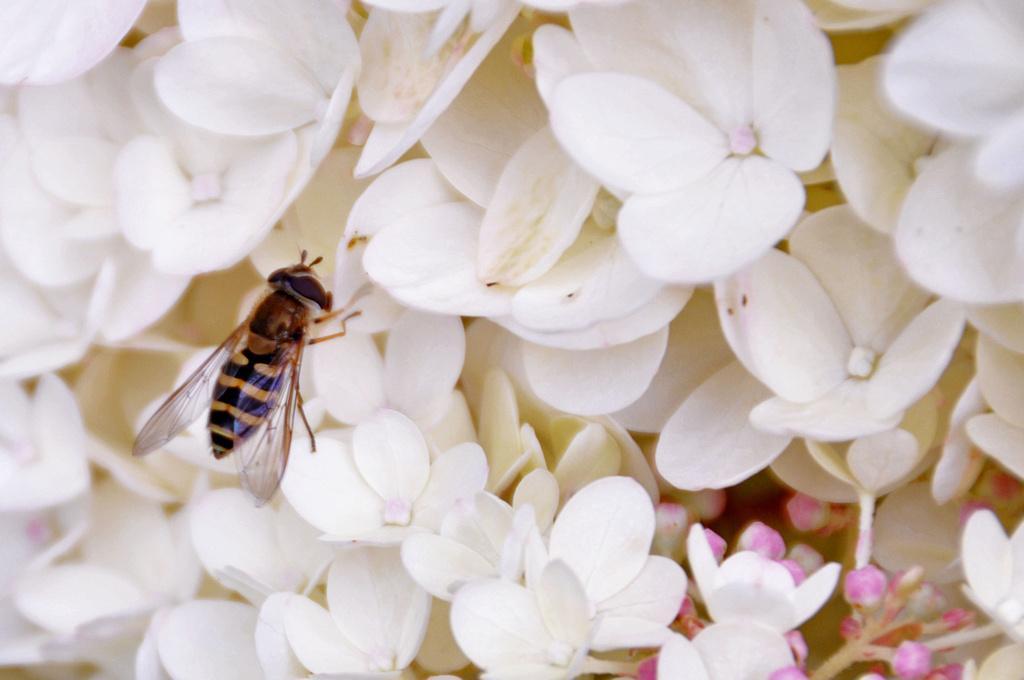Can you describe this image briefly? In this image I can see number of white colour flowers and on the left side I can see an insect on the flower. On the bottom right side of this image I can see number of pink colour buds. 